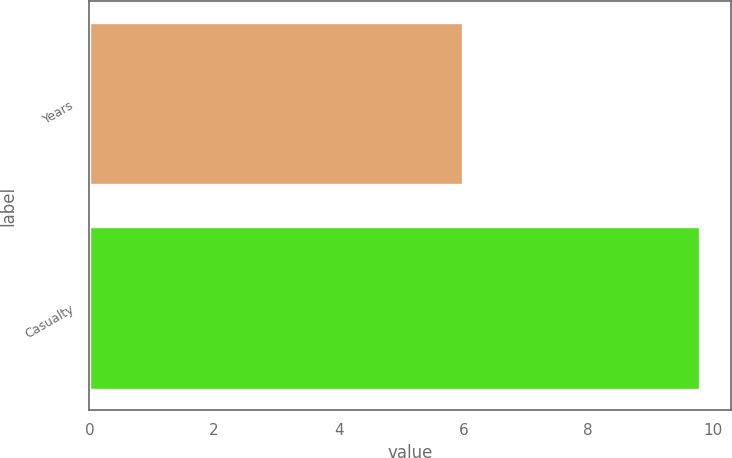Convert chart. <chart><loc_0><loc_0><loc_500><loc_500><bar_chart><fcel>Years<fcel>Casualty<nl><fcel>6<fcel>9.8<nl></chart> 